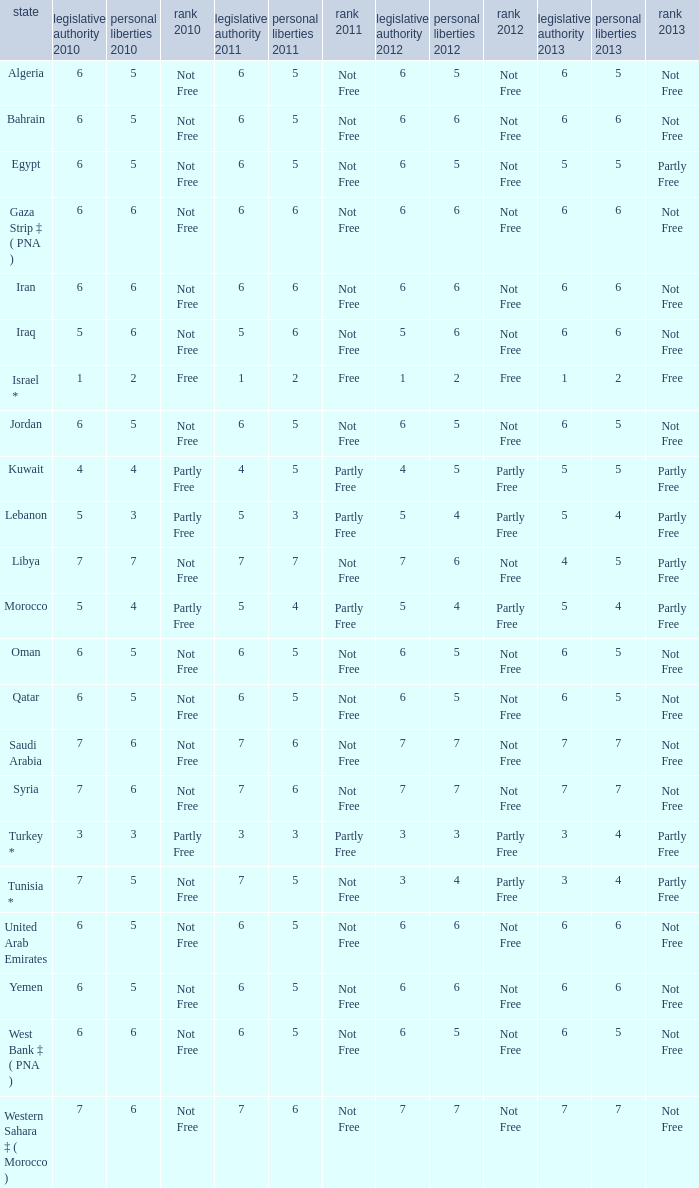How many civil liberties 2013 values are associated with a 2010 political rights value of 6, civil liberties 2012 values over 5, and political rights 2011 under 6? 0.0. 